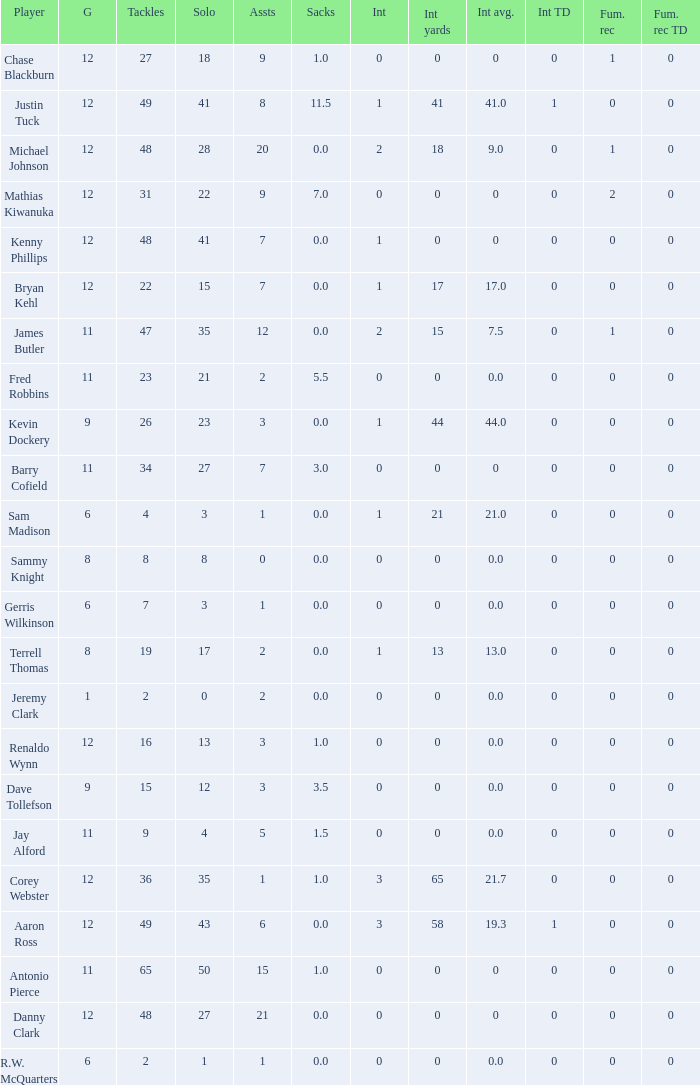Name the least int yards when sacks is 11.5 41.0. 